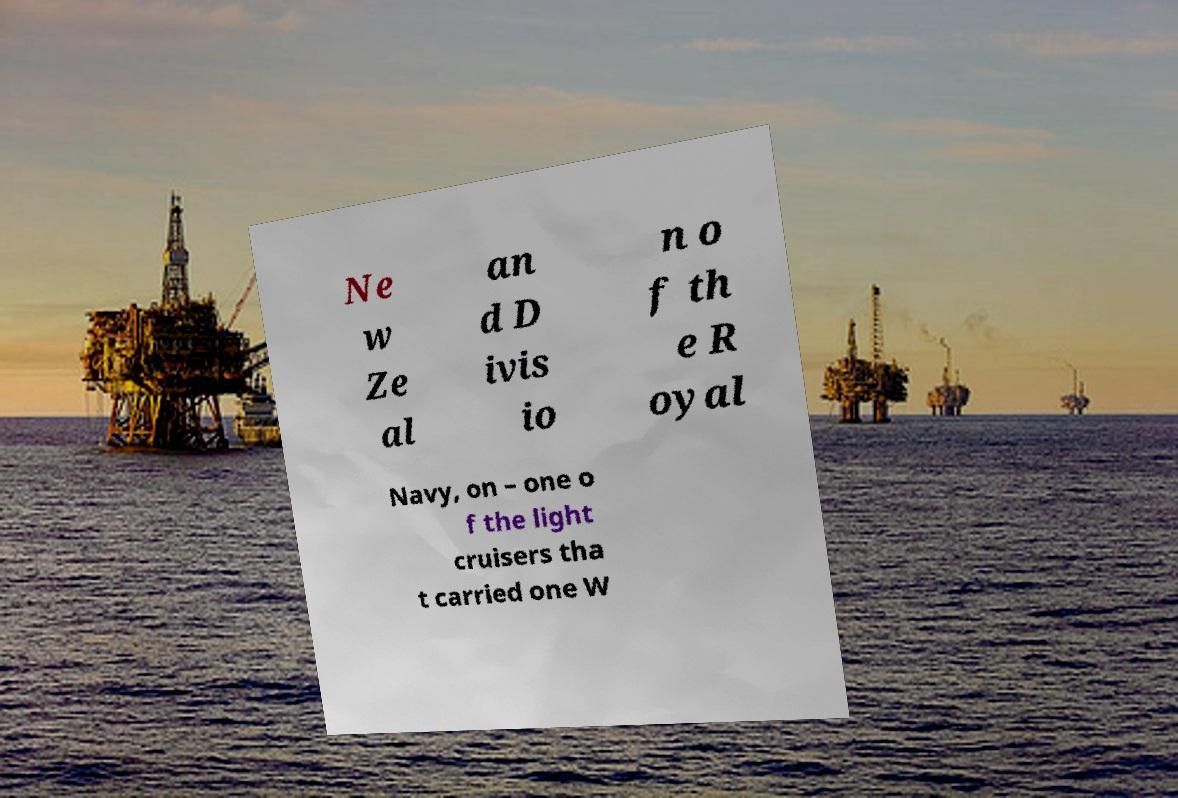Could you extract and type out the text from this image? Ne w Ze al an d D ivis io n o f th e R oyal Navy, on – one o f the light cruisers tha t carried one W 